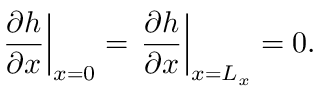Convert formula to latex. <formula><loc_0><loc_0><loc_500><loc_500>\frac { \partial h } { \partial x } \right | _ { x = 0 } = \frac { \partial h } { \partial x } \right | _ { x = L _ { x } } = 0 .</formula> 